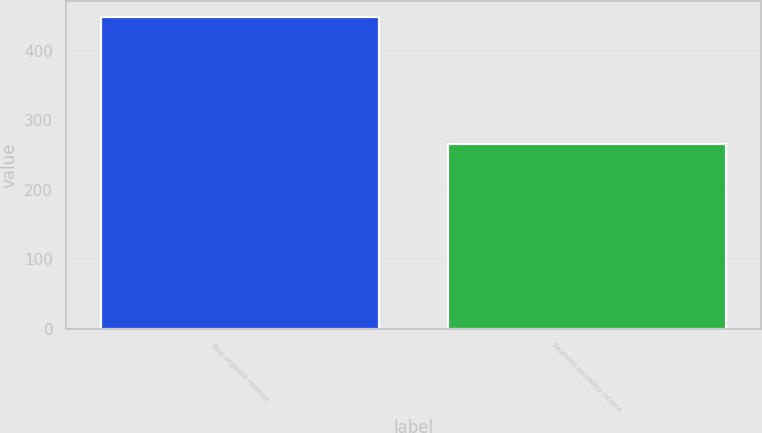<chart> <loc_0><loc_0><loc_500><loc_500><bar_chart><fcel>Total segment revenue<fcel>Segment operating income<nl><fcel>449<fcel>266<nl></chart> 